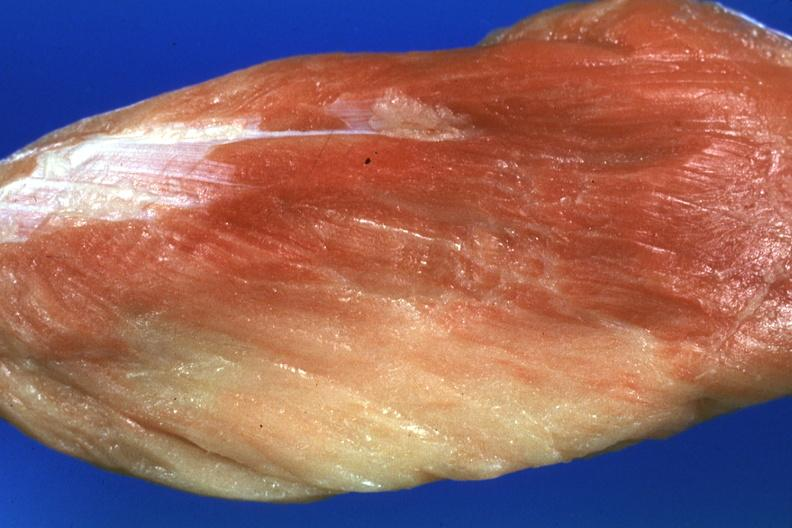how does this image show close-up?
Answer the question using a single word or phrase. With some red muscle remaining 